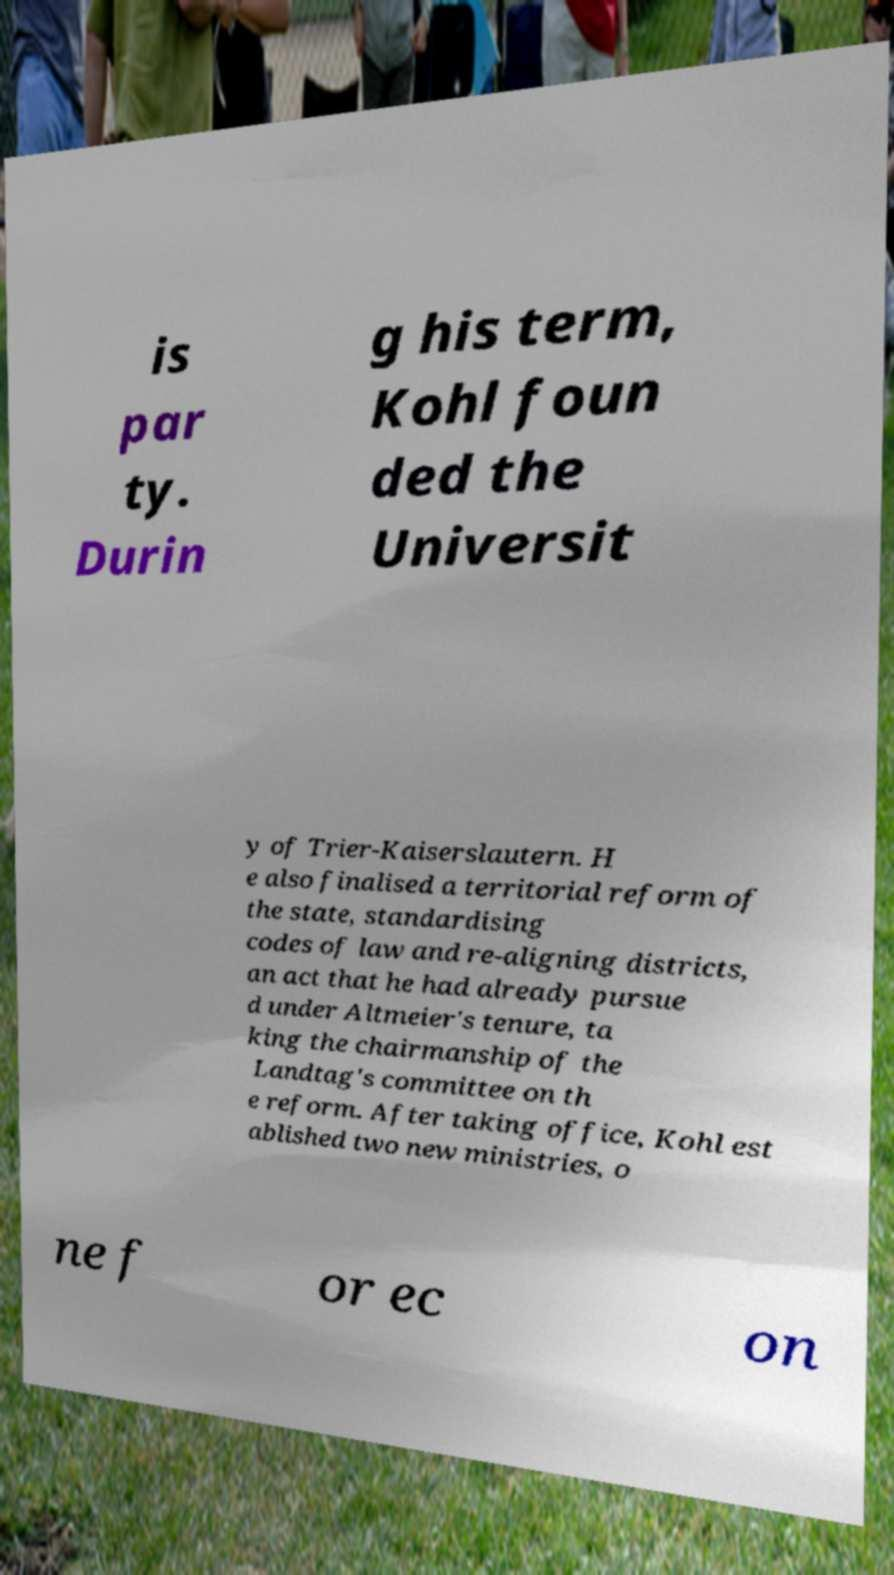Could you assist in decoding the text presented in this image and type it out clearly? is par ty. Durin g his term, Kohl foun ded the Universit y of Trier-Kaiserslautern. H e also finalised a territorial reform of the state, standardising codes of law and re-aligning districts, an act that he had already pursue d under Altmeier's tenure, ta king the chairmanship of the Landtag's committee on th e reform. After taking office, Kohl est ablished two new ministries, o ne f or ec on 